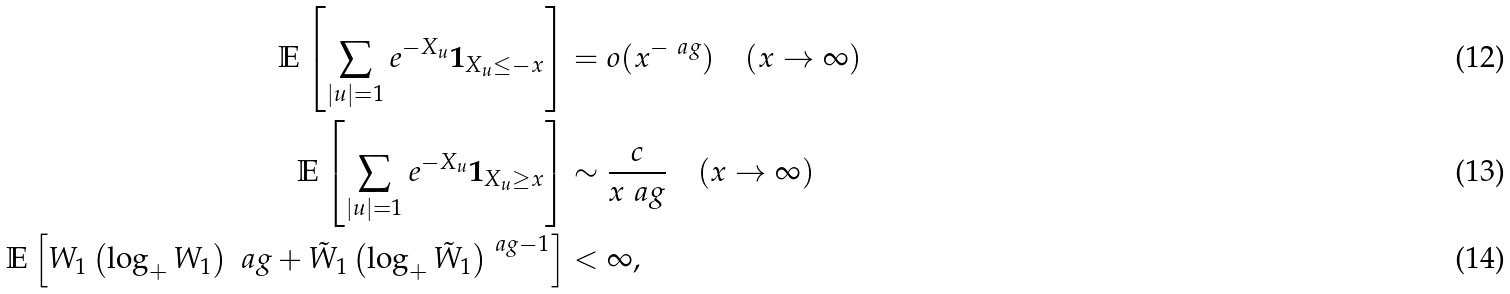Convert formula to latex. <formula><loc_0><loc_0><loc_500><loc_500>\mathbb { E } \left [ \sum _ { | u | = 1 } e ^ { - X _ { u } } \boldsymbol 1 _ { X _ { u } \leq - x } \right ] & = o ( x ^ { - \ a g } ) \quad ( x \to \infty ) \\ \mathbb { E } \left [ \sum _ { | u | = 1 } e ^ { - X _ { u } } \boldsymbol 1 _ { X _ { u } \geq x } \right ] & \sim \frac { c } { x ^ { \ } a g } \quad ( x \to \infty ) \\ \mathbb { E } \left [ W _ { 1 } \left ( \log _ { + } W _ { 1 } \right ) ^ { \ } a g + \tilde { W } _ { 1 } \left ( \log _ { + } \tilde { W } _ { 1 } \right ) ^ { \ a g - 1 } \right ] & < \infty ,</formula> 